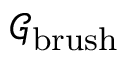Convert formula to latex. <formula><loc_0><loc_0><loc_500><loc_500>\mathcal { G } _ { b r u s h }</formula> 